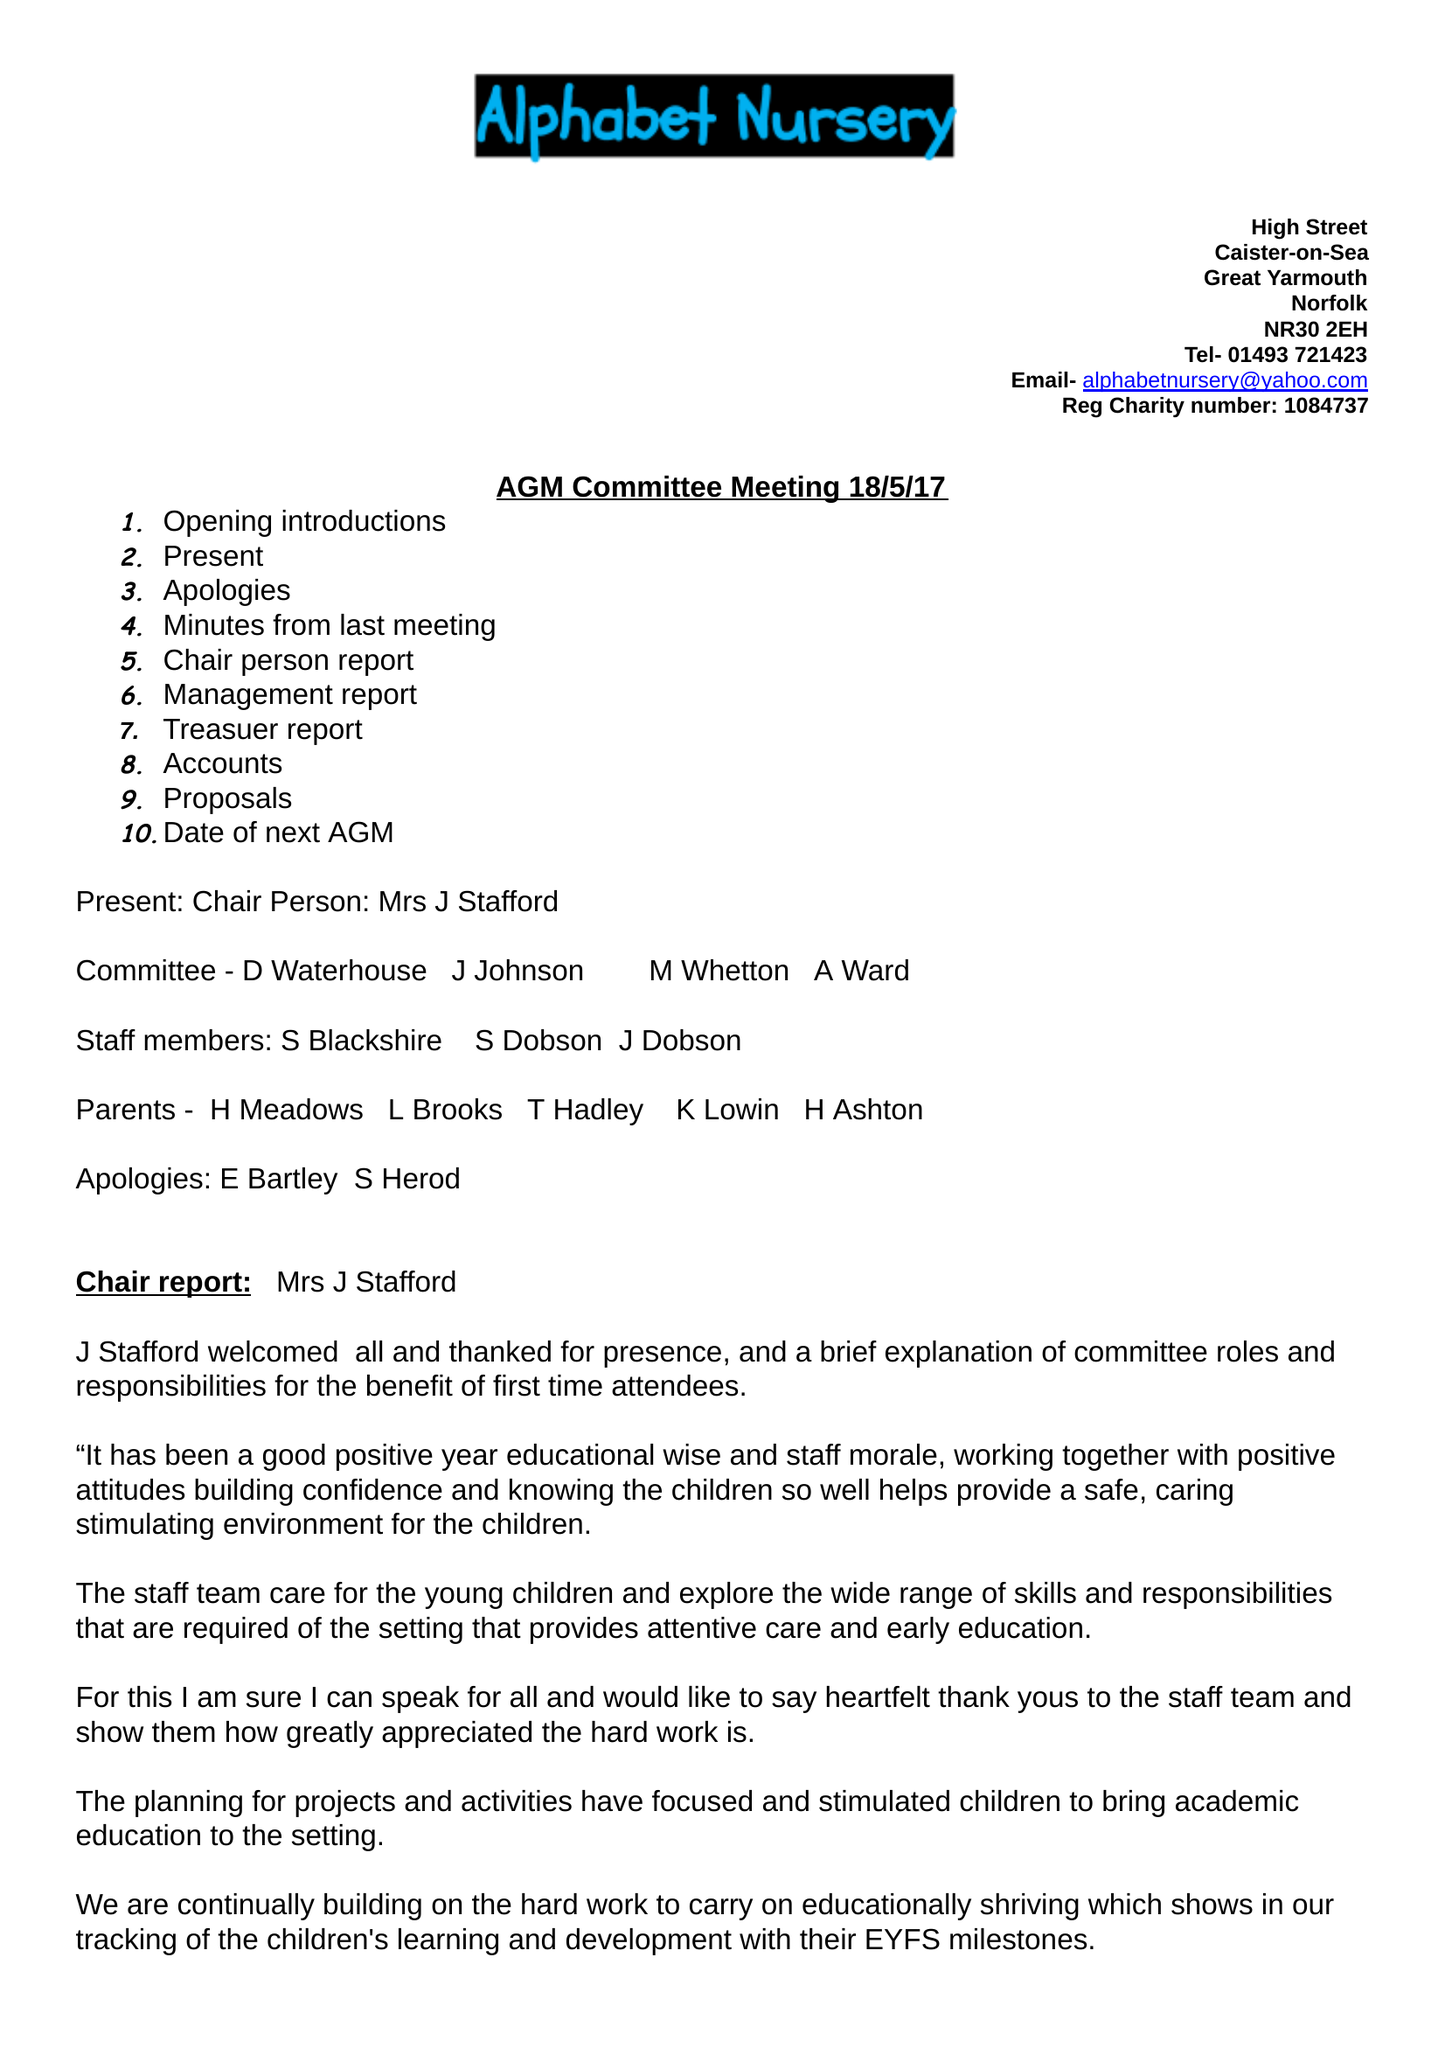What is the value for the address__postcode?
Answer the question using a single word or phrase. NR29 5AR 